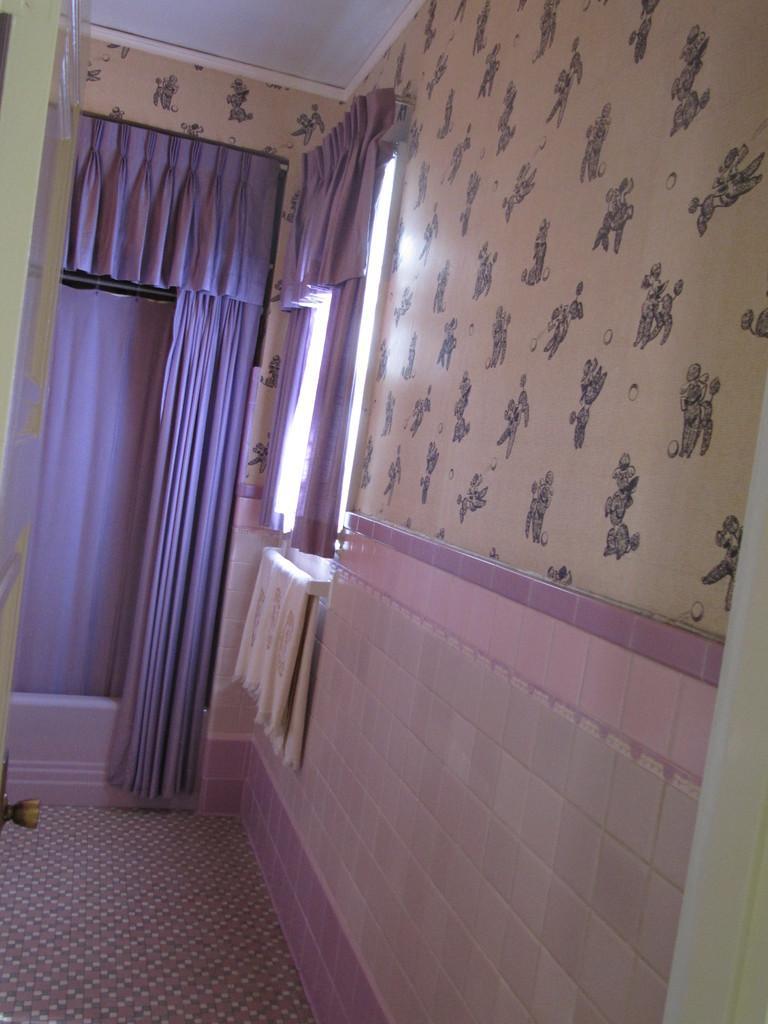Describe this image in one or two sentences. This is an inside picture of the room, we can see some curtains, window and the wall with some design. 